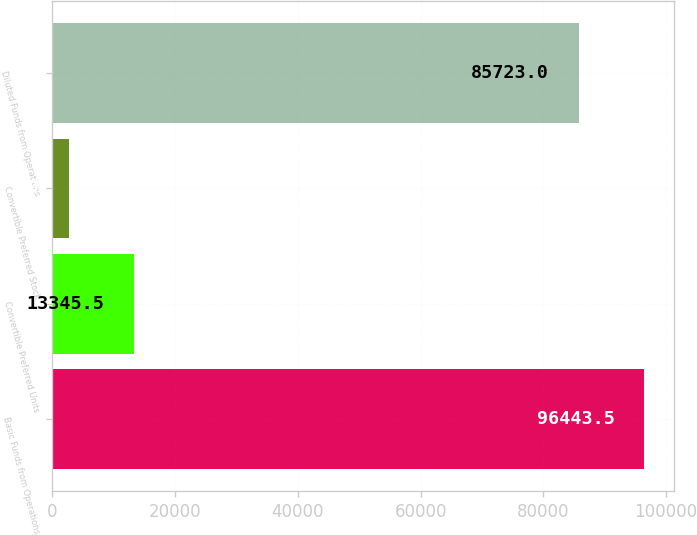Convert chart to OTSL. <chart><loc_0><loc_0><loc_500><loc_500><bar_chart><fcel>Basic Funds from Operations<fcel>Convertible Preferred Units<fcel>Convertible Preferred Stock<fcel>Diluted Funds from Operations<nl><fcel>96443.5<fcel>13345.5<fcel>2625<fcel>85723<nl></chart> 